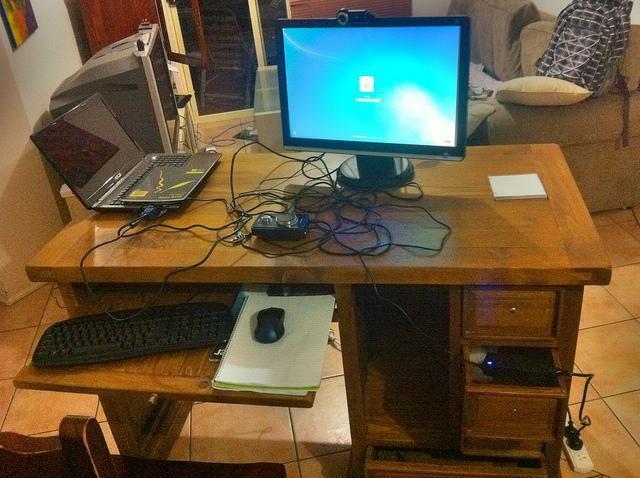How many tvs are there?
Give a very brief answer. 2. How many chairs are in the photo?
Give a very brief answer. 2. 